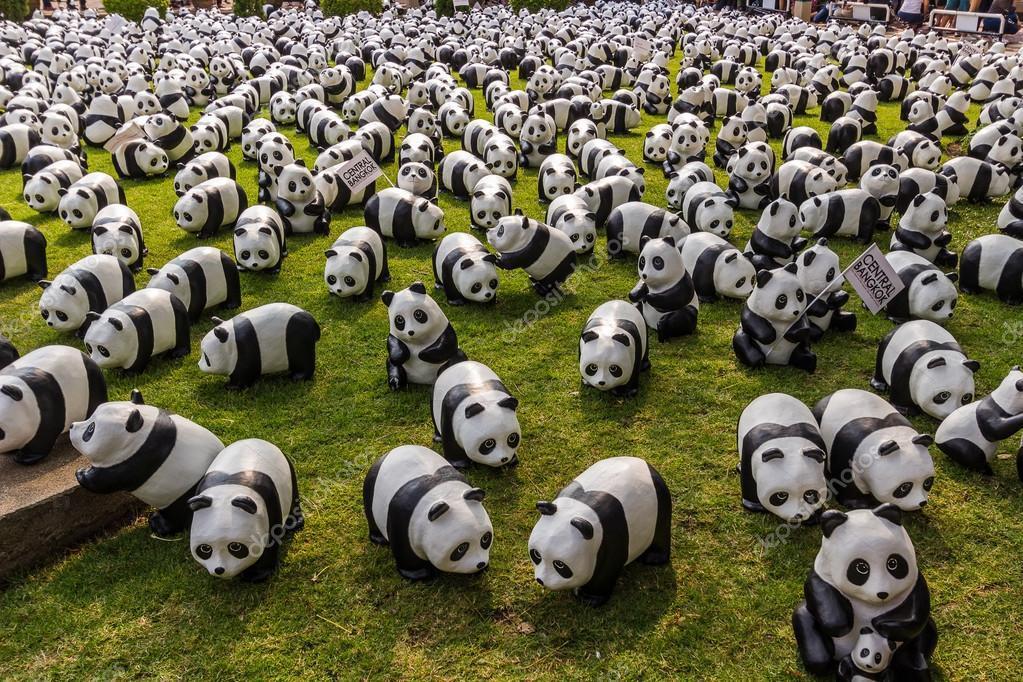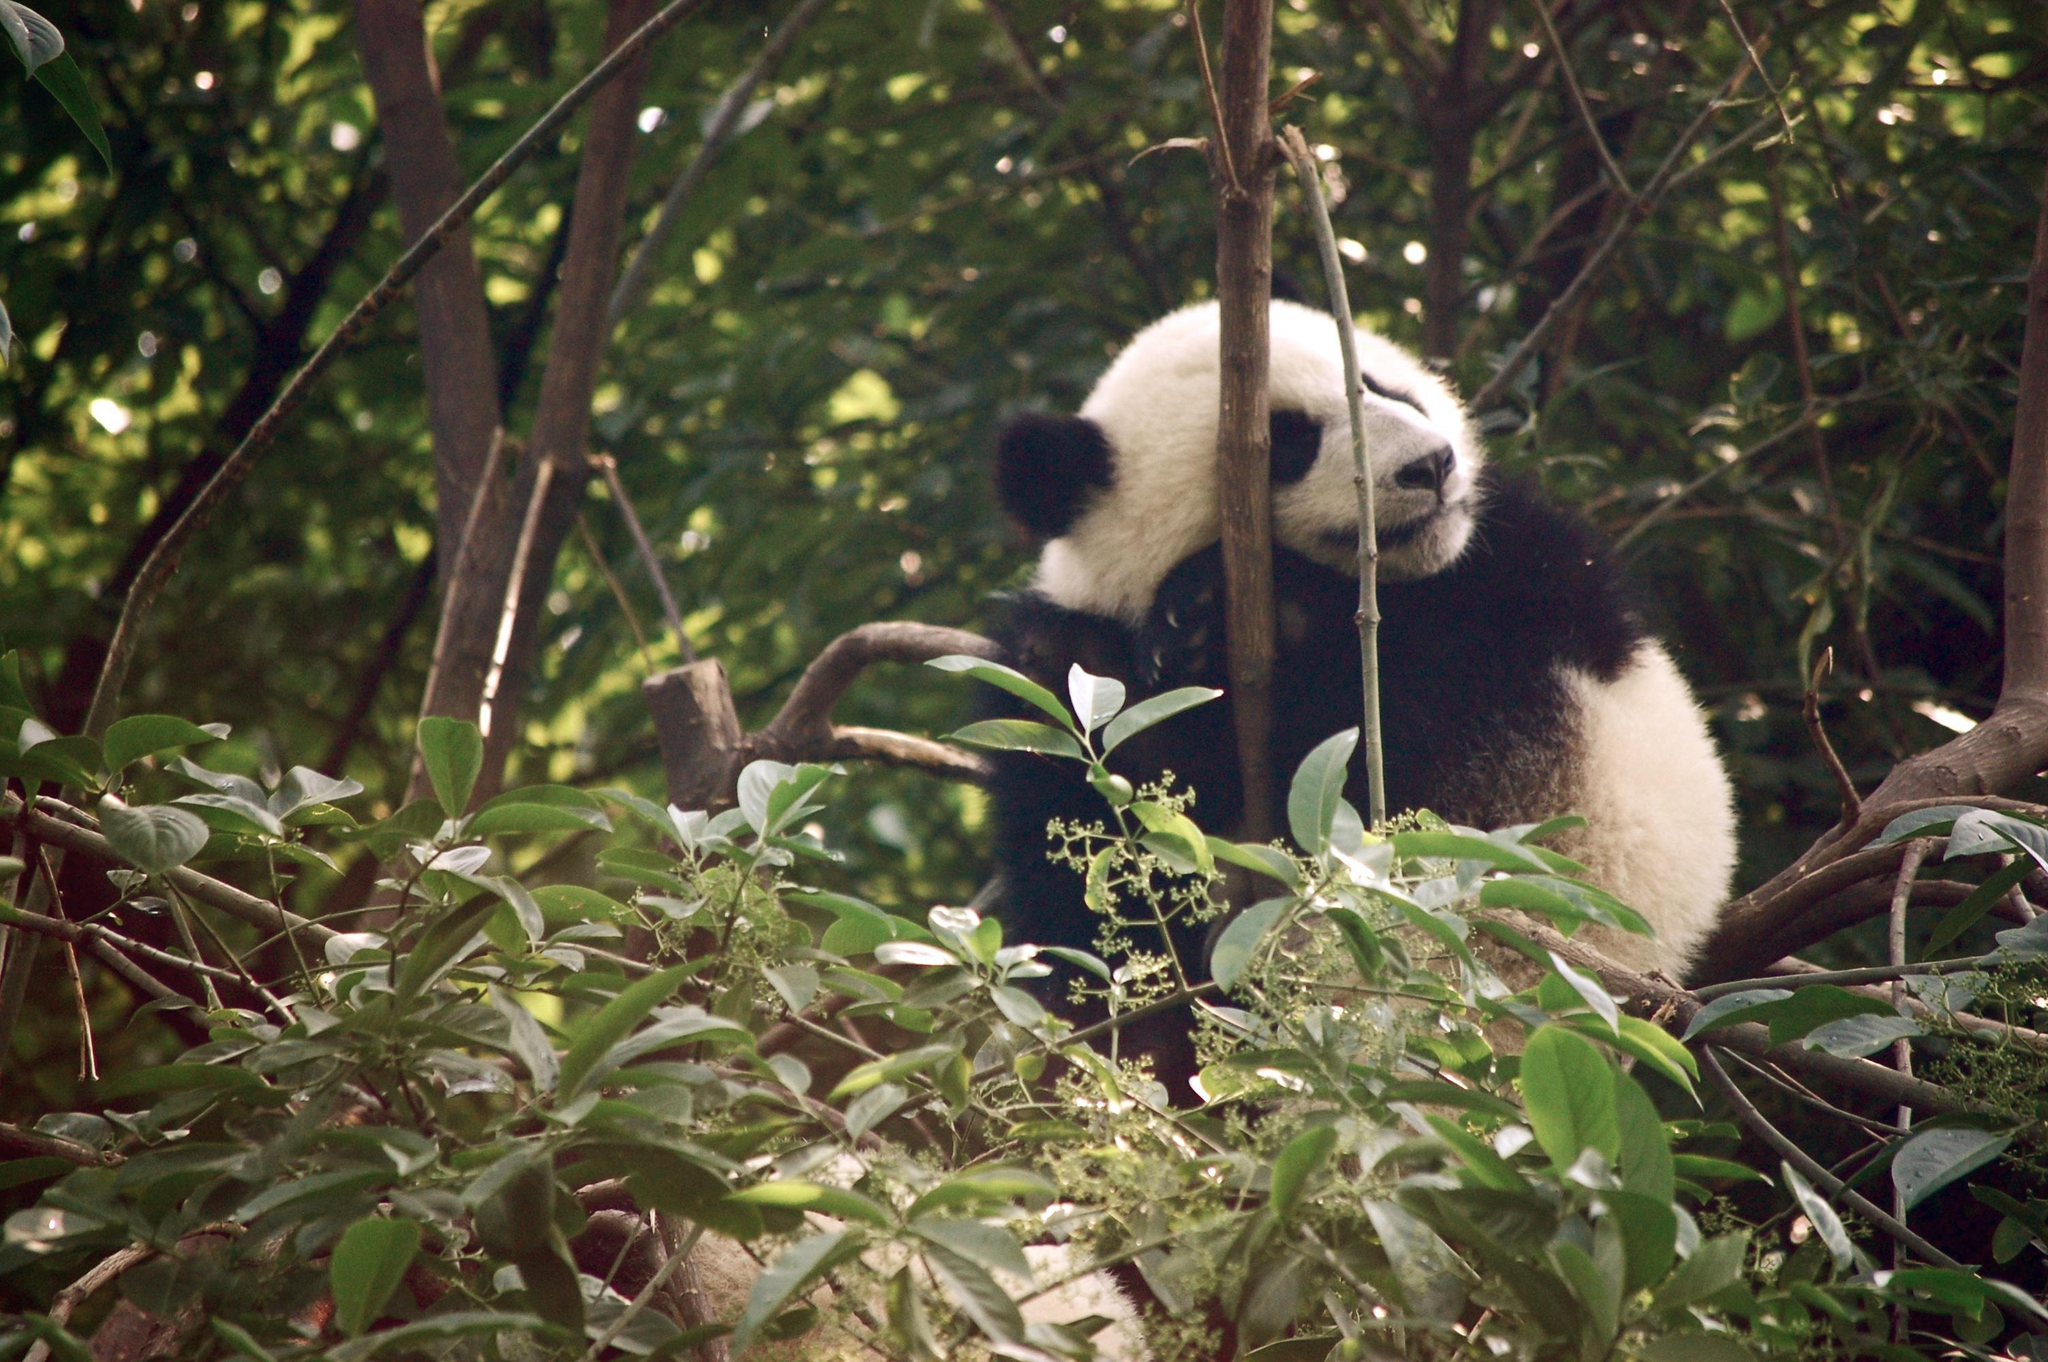The first image is the image on the left, the second image is the image on the right. For the images displayed, is the sentence "There is a single panda in one of the images." factually correct? Answer yes or no. Yes. 